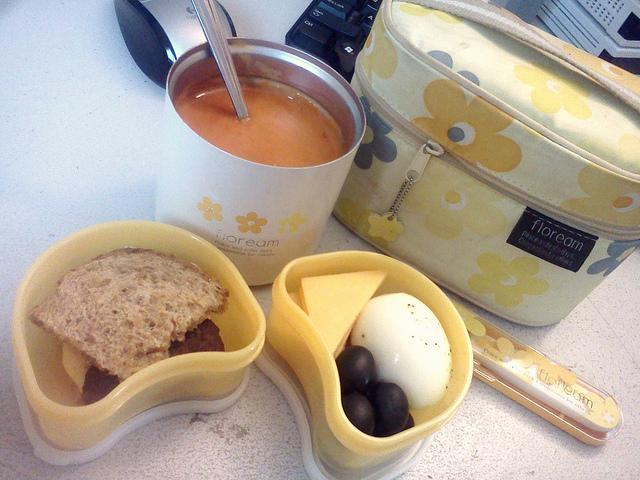What does the item in the can with the utensil look like? Please explain your reasoning. soup. The can design is consistent with something that would be used to insulate food and keep it at a certain temperature. the liquid inside the container looks to be of the consistency of soup and is likely soup because of the container it is in. 